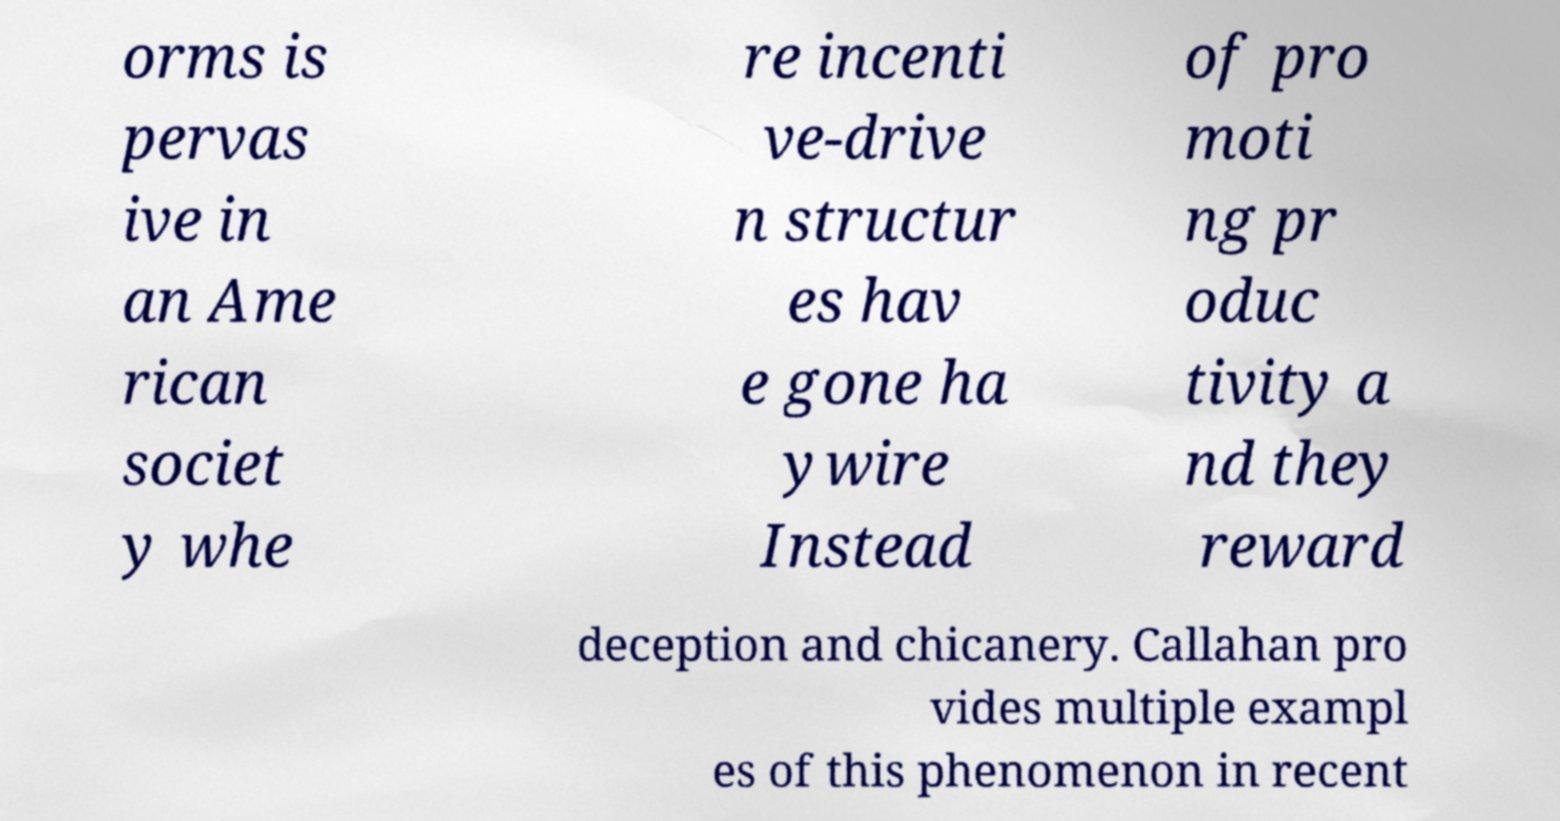Please read and relay the text visible in this image. What does it say? orms is pervas ive in an Ame rican societ y whe re incenti ve-drive n structur es hav e gone ha ywire Instead of pro moti ng pr oduc tivity a nd they reward deception and chicanery. Callahan pro vides multiple exampl es of this phenomenon in recent 